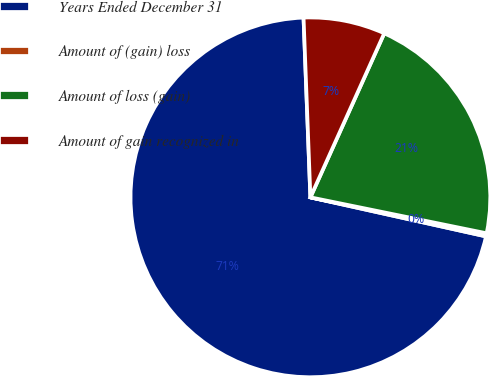Convert chart to OTSL. <chart><loc_0><loc_0><loc_500><loc_500><pie_chart><fcel>Years Ended December 31<fcel>Amount of (gain) loss<fcel>Amount of loss (gain)<fcel>Amount of gain recognized in<nl><fcel>70.91%<fcel>0.28%<fcel>21.47%<fcel>7.34%<nl></chart> 